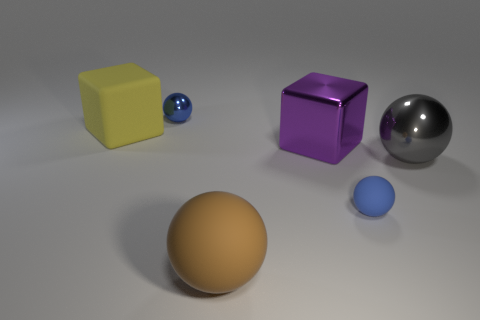There is a object that is on the right side of the tiny blue metallic object and behind the large gray metallic sphere; what size is it?
Your answer should be very brief. Large. Is there a large yellow thing made of the same material as the brown ball?
Offer a terse response. Yes. What size is the metallic thing that is the same color as the small rubber ball?
Offer a very short reply. Small. There is a small blue object that is left of the matte ball that is in front of the small blue rubber object; what is it made of?
Your answer should be very brief. Metal. How many other balls have the same color as the small shiny sphere?
Ensure brevity in your answer.  1. What is the size of the brown ball that is made of the same material as the yellow block?
Your response must be concise. Large. There is a small blue thing in front of the tiny shiny ball; what shape is it?
Provide a succinct answer. Sphere. There is a blue rubber object that is the same shape as the tiny metal thing; what size is it?
Ensure brevity in your answer.  Small. There is a tiny thing that is in front of the small blue object behind the yellow thing; what number of metallic spheres are left of it?
Keep it short and to the point. 1. Is the number of big cubes that are behind the large purple shiny thing the same as the number of small metallic balls?
Your response must be concise. Yes. 